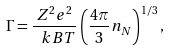Convert formula to latex. <formula><loc_0><loc_0><loc_500><loc_500>\Gamma = \frac { Z ^ { 2 } e ^ { 2 } } { \ k B T } \left ( \frac { 4 \pi } { 3 } n _ { N } \right ) ^ { 1 / 3 } ,</formula> 